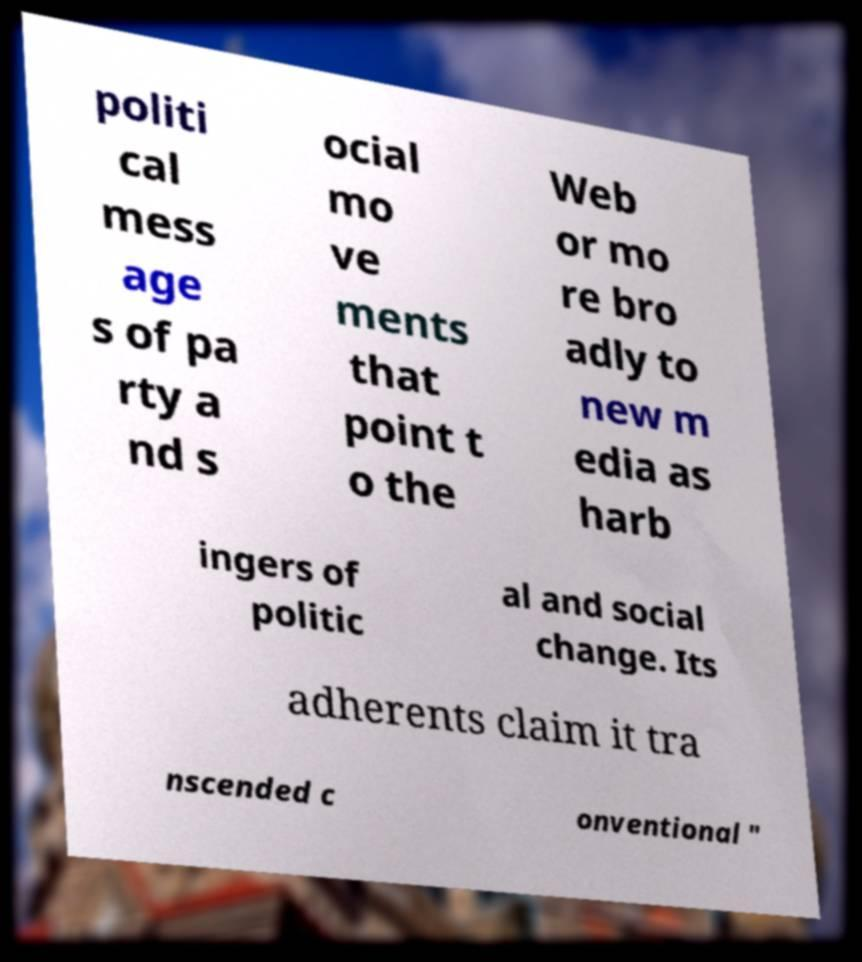I need the written content from this picture converted into text. Can you do that? politi cal mess age s of pa rty a nd s ocial mo ve ments that point t o the Web or mo re bro adly to new m edia as harb ingers of politic al and social change. Its adherents claim it tra nscended c onventional " 